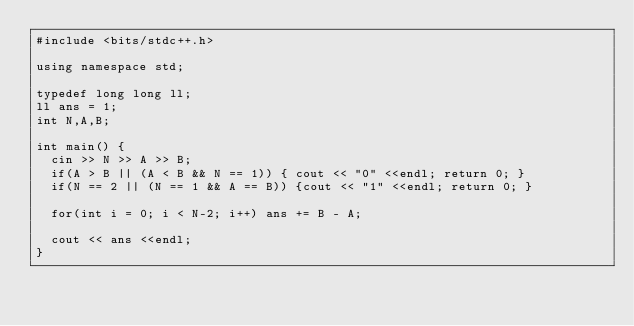Convert code to text. <code><loc_0><loc_0><loc_500><loc_500><_C++_>#include <bits/stdc++.h>

using namespace std;

typedef long long ll;
ll ans = 1;
int N,A,B;

int main() {
  cin >> N >> A >> B;
  if(A > B || (A < B && N == 1)) { cout << "0" <<endl; return 0; }
  if(N == 2 || (N == 1 && A == B)) {cout << "1" <<endl; return 0; }

  for(int i = 0; i < N-2; i++) ans += B - A;

  cout << ans <<endl;
}

    
  
</code> 